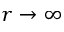Convert formula to latex. <formula><loc_0><loc_0><loc_500><loc_500>r \to \infty</formula> 